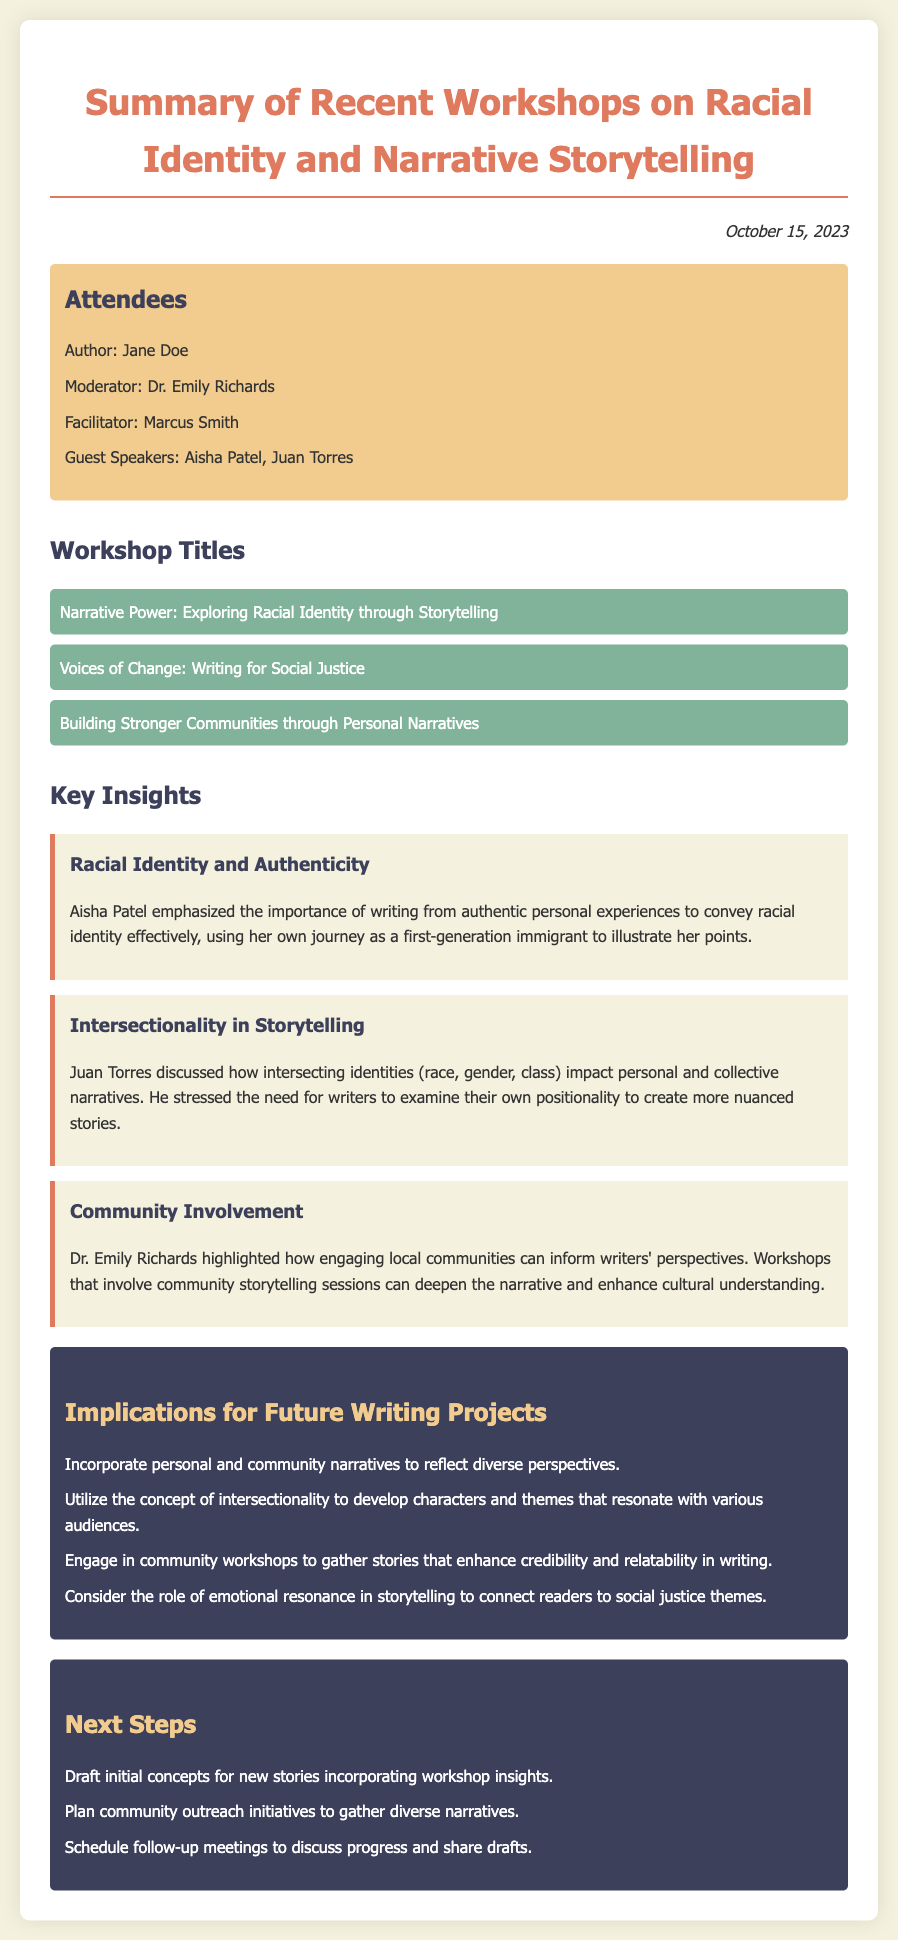What is the date of the meeting minutes? The date listed in the document is presented at the top, indicating when the meeting occurred.
Answer: October 15, 2023 Who moderated the workshop? The document identifies the role of the moderator among the attendees.
Answer: Dr. Emily Richards What was one of the workshop titles? The titles of the workshops are listed in the document, providing specific topics covered.
Answer: Narrative Power: Exploring Racial Identity through Storytelling What key insight was emphasized by Aisha Patel? The document details insights from guest speakers, highlighting their main points.
Answer: Authentic personal experiences How many implications for future writing projects are listed? The number of items in the implications section can be counted directly from the document.
Answer: Four What is a suggested next step mentioned in the minutes? The next steps section outlines specific actions to take after the workshops.
Answer: Plan community outreach initiatives What is the focus of Juan Torres's discussion? The document describes the main topic of one of the guest speaker's discussions.
Answer: Intersectionality in storytelling What color is used for the implications section? The document specifies the colors used for different sections, including the implications.
Answer: Dark grey Which attendee is identified as a facilitator? The attendees' roles are specified, including who facilitated the workshops.
Answer: Marcus Smith 